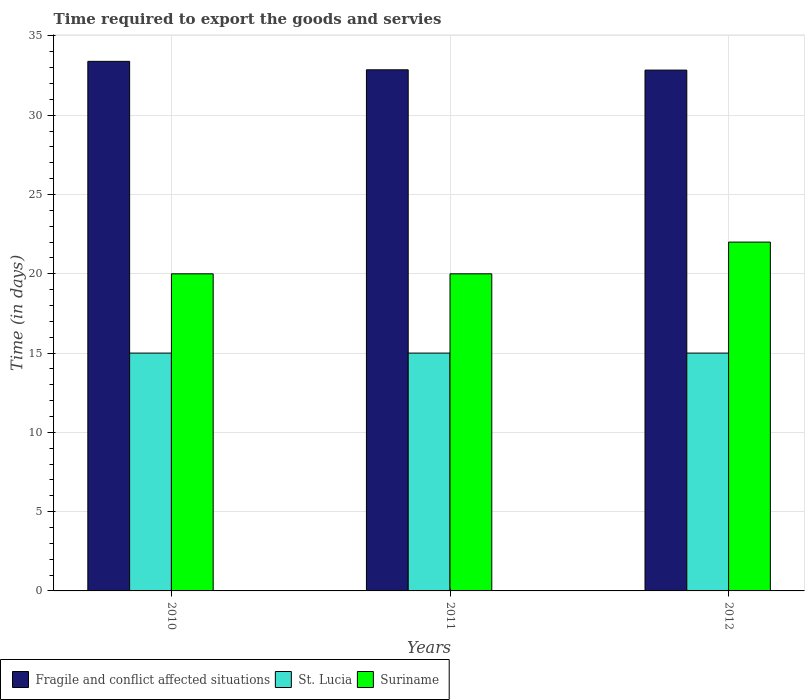Are the number of bars on each tick of the X-axis equal?
Your response must be concise. Yes. How many bars are there on the 2nd tick from the left?
Give a very brief answer. 3. How many bars are there on the 2nd tick from the right?
Your response must be concise. 3. What is the number of days required to export the goods and services in Fragile and conflict affected situations in 2010?
Your answer should be compact. 33.4. Across all years, what is the maximum number of days required to export the goods and services in Suriname?
Give a very brief answer. 22. Across all years, what is the minimum number of days required to export the goods and services in St. Lucia?
Your answer should be very brief. 15. In which year was the number of days required to export the goods and services in St. Lucia maximum?
Give a very brief answer. 2010. In which year was the number of days required to export the goods and services in Suriname minimum?
Keep it short and to the point. 2010. What is the total number of days required to export the goods and services in St. Lucia in the graph?
Your answer should be compact. 45. What is the difference between the number of days required to export the goods and services in Suriname in 2011 and that in 2012?
Your response must be concise. -2. What is the difference between the number of days required to export the goods and services in Suriname in 2011 and the number of days required to export the goods and services in Fragile and conflict affected situations in 2012?
Your answer should be compact. -12.85. What is the average number of days required to export the goods and services in St. Lucia per year?
Ensure brevity in your answer.  15. Is the number of days required to export the goods and services in Fragile and conflict affected situations in 2011 less than that in 2012?
Your answer should be compact. No. Is the difference between the number of days required to export the goods and services in Fragile and conflict affected situations in 2011 and 2012 greater than the difference between the number of days required to export the goods and services in St. Lucia in 2011 and 2012?
Make the answer very short. Yes. Is the sum of the number of days required to export the goods and services in Suriname in 2011 and 2012 greater than the maximum number of days required to export the goods and services in Fragile and conflict affected situations across all years?
Give a very brief answer. Yes. What does the 1st bar from the left in 2012 represents?
Your answer should be very brief. Fragile and conflict affected situations. What does the 3rd bar from the right in 2012 represents?
Ensure brevity in your answer.  Fragile and conflict affected situations. Is it the case that in every year, the sum of the number of days required to export the goods and services in Suriname and number of days required to export the goods and services in St. Lucia is greater than the number of days required to export the goods and services in Fragile and conflict affected situations?
Your answer should be compact. Yes. What is the difference between two consecutive major ticks on the Y-axis?
Your answer should be very brief. 5. Are the values on the major ticks of Y-axis written in scientific E-notation?
Make the answer very short. No. Where does the legend appear in the graph?
Your answer should be very brief. Bottom left. What is the title of the graph?
Your answer should be compact. Time required to export the goods and servies. Does "New Zealand" appear as one of the legend labels in the graph?
Ensure brevity in your answer.  No. What is the label or title of the Y-axis?
Keep it short and to the point. Time (in days). What is the Time (in days) in Fragile and conflict affected situations in 2010?
Your answer should be compact. 33.4. What is the Time (in days) of St. Lucia in 2010?
Your answer should be compact. 15. What is the Time (in days) in Suriname in 2010?
Keep it short and to the point. 20. What is the Time (in days) of Fragile and conflict affected situations in 2011?
Ensure brevity in your answer.  32.87. What is the Time (in days) of Fragile and conflict affected situations in 2012?
Offer a very short reply. 32.85. What is the Time (in days) in St. Lucia in 2012?
Offer a very short reply. 15. Across all years, what is the maximum Time (in days) in Fragile and conflict affected situations?
Your answer should be compact. 33.4. Across all years, what is the minimum Time (in days) in Fragile and conflict affected situations?
Provide a succinct answer. 32.85. Across all years, what is the minimum Time (in days) in Suriname?
Your answer should be compact. 20. What is the total Time (in days) of Fragile and conflict affected situations in the graph?
Offer a very short reply. 99.12. What is the total Time (in days) of St. Lucia in the graph?
Provide a succinct answer. 45. What is the total Time (in days) in Suriname in the graph?
Make the answer very short. 62. What is the difference between the Time (in days) of Fragile and conflict affected situations in 2010 and that in 2011?
Your response must be concise. 0.53. What is the difference between the Time (in days) in St. Lucia in 2010 and that in 2011?
Make the answer very short. 0. What is the difference between the Time (in days) of Suriname in 2010 and that in 2011?
Your answer should be compact. 0. What is the difference between the Time (in days) of Fragile and conflict affected situations in 2010 and that in 2012?
Give a very brief answer. 0.55. What is the difference between the Time (in days) in Fragile and conflict affected situations in 2011 and that in 2012?
Provide a succinct answer. 0.02. What is the difference between the Time (in days) of St. Lucia in 2011 and that in 2012?
Make the answer very short. 0. What is the difference between the Time (in days) in Fragile and conflict affected situations in 2010 and the Time (in days) in St. Lucia in 2011?
Make the answer very short. 18.4. What is the difference between the Time (in days) in Fragile and conflict affected situations in 2010 and the Time (in days) in Suriname in 2012?
Offer a very short reply. 11.4. What is the difference between the Time (in days) in Fragile and conflict affected situations in 2011 and the Time (in days) in St. Lucia in 2012?
Your response must be concise. 17.87. What is the difference between the Time (in days) of Fragile and conflict affected situations in 2011 and the Time (in days) of Suriname in 2012?
Ensure brevity in your answer.  10.87. What is the average Time (in days) in Fragile and conflict affected situations per year?
Your answer should be very brief. 33.04. What is the average Time (in days) of Suriname per year?
Offer a terse response. 20.67. In the year 2011, what is the difference between the Time (in days) of Fragile and conflict affected situations and Time (in days) of St. Lucia?
Ensure brevity in your answer.  17.87. In the year 2011, what is the difference between the Time (in days) of Fragile and conflict affected situations and Time (in days) of Suriname?
Ensure brevity in your answer.  12.87. In the year 2012, what is the difference between the Time (in days) in Fragile and conflict affected situations and Time (in days) in St. Lucia?
Ensure brevity in your answer.  17.85. In the year 2012, what is the difference between the Time (in days) of Fragile and conflict affected situations and Time (in days) of Suriname?
Provide a succinct answer. 10.85. In the year 2012, what is the difference between the Time (in days) of St. Lucia and Time (in days) of Suriname?
Give a very brief answer. -7. What is the ratio of the Time (in days) in Fragile and conflict affected situations in 2010 to that in 2011?
Offer a terse response. 1.02. What is the ratio of the Time (in days) in Suriname in 2010 to that in 2011?
Provide a succinct answer. 1. What is the ratio of the Time (in days) in Fragile and conflict affected situations in 2010 to that in 2012?
Ensure brevity in your answer.  1.02. What is the ratio of the Time (in days) in St. Lucia in 2010 to that in 2012?
Offer a very short reply. 1. What is the ratio of the Time (in days) of St. Lucia in 2011 to that in 2012?
Offer a terse response. 1. What is the ratio of the Time (in days) of Suriname in 2011 to that in 2012?
Give a very brief answer. 0.91. What is the difference between the highest and the second highest Time (in days) in Fragile and conflict affected situations?
Your response must be concise. 0.53. What is the difference between the highest and the second highest Time (in days) of St. Lucia?
Provide a succinct answer. 0. What is the difference between the highest and the second highest Time (in days) in Suriname?
Provide a succinct answer. 2. What is the difference between the highest and the lowest Time (in days) of Fragile and conflict affected situations?
Your answer should be very brief. 0.55. What is the difference between the highest and the lowest Time (in days) in St. Lucia?
Give a very brief answer. 0. 